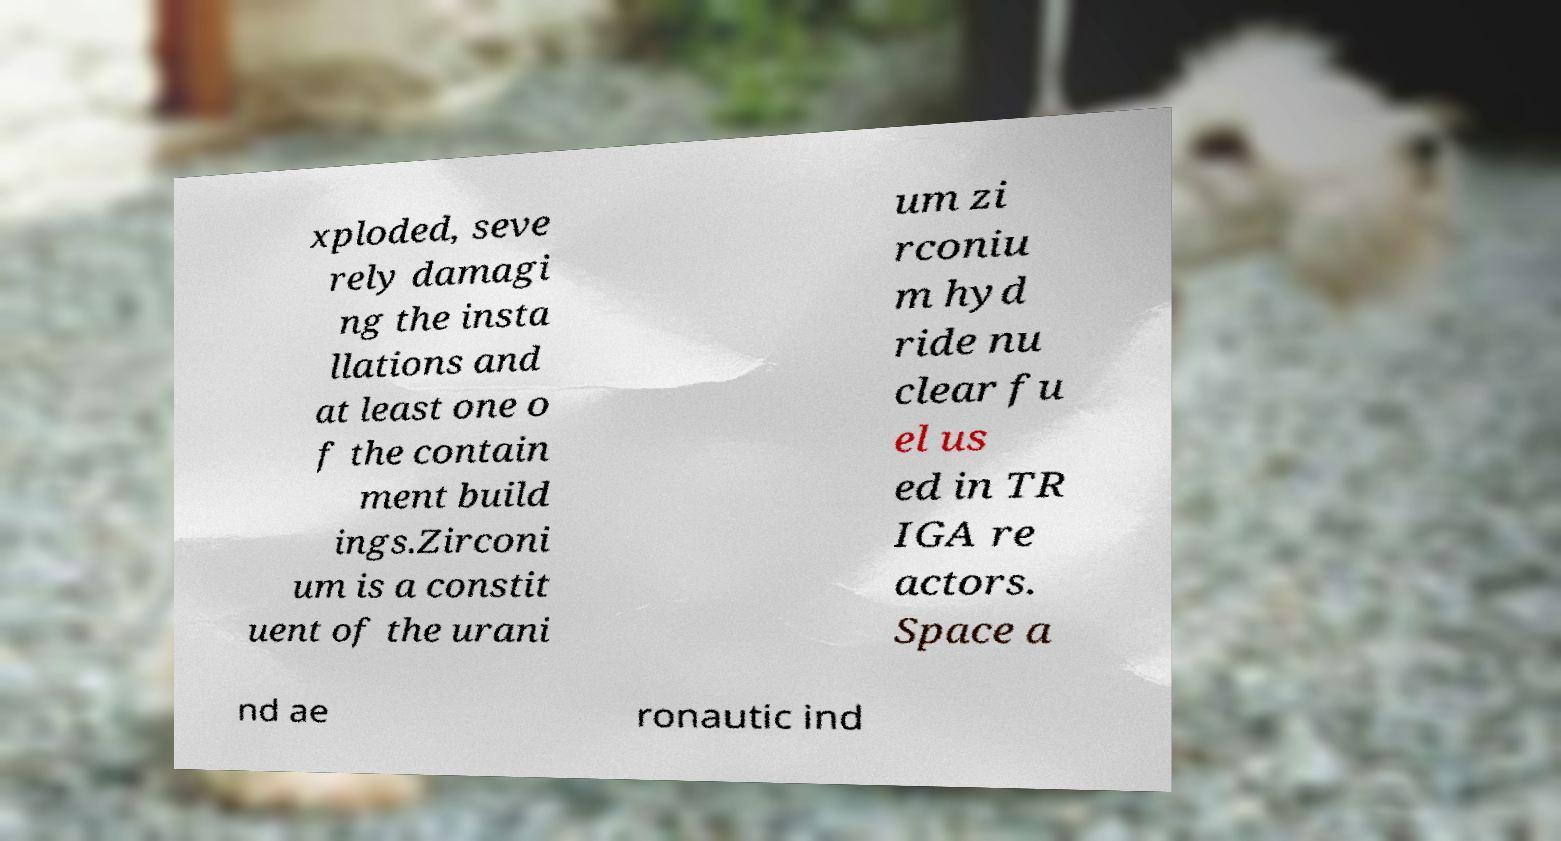Could you extract and type out the text from this image? xploded, seve rely damagi ng the insta llations and at least one o f the contain ment build ings.Zirconi um is a constit uent of the urani um zi rconiu m hyd ride nu clear fu el us ed in TR IGA re actors. Space a nd ae ronautic ind 